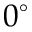Convert formula to latex. <formula><loc_0><loc_0><loc_500><loc_500>0 ^ { \circ }</formula> 